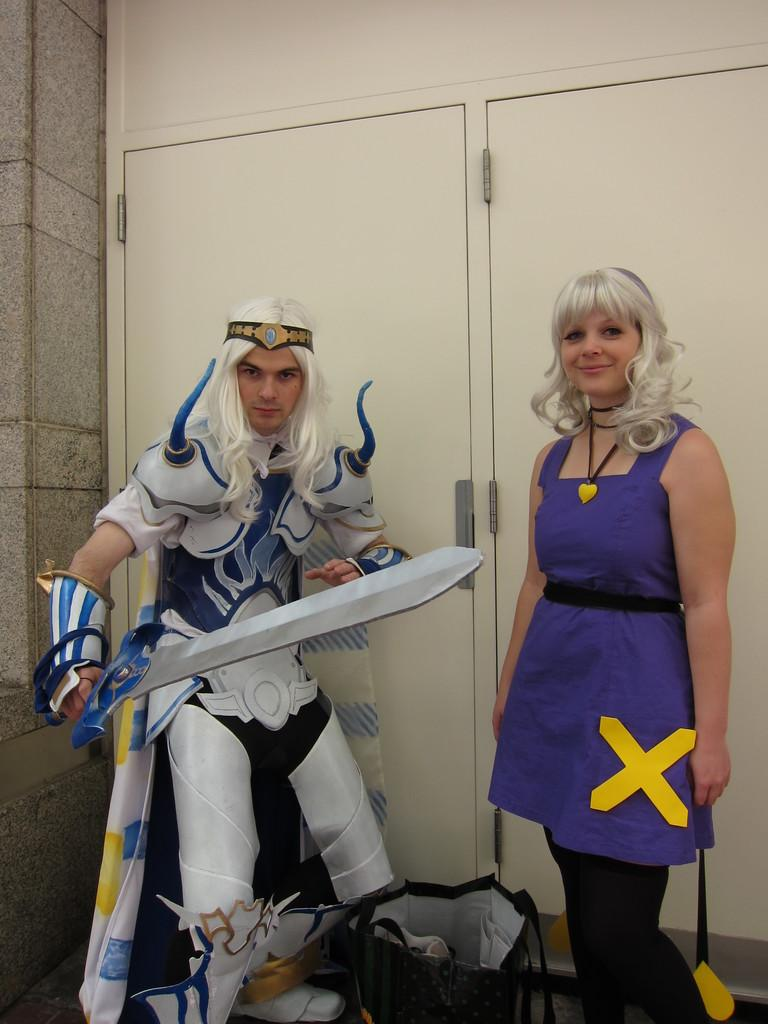Who is on the right side of the image? There is a lady on the right side of the image. What is the person wearing in the image? There is a person wearing a costume in the image. What is the person holding in the costume? The person in the costume is holding a sword. What can be seen in the background of the image? There are doors visible in the background of the image. What type of van is parked near the doors in the image? There is no van present in the image; only a lady, a person in a costume, a sword, and doors are visible. Is there a railway track visible in the image? There is no railway track present in the image. 